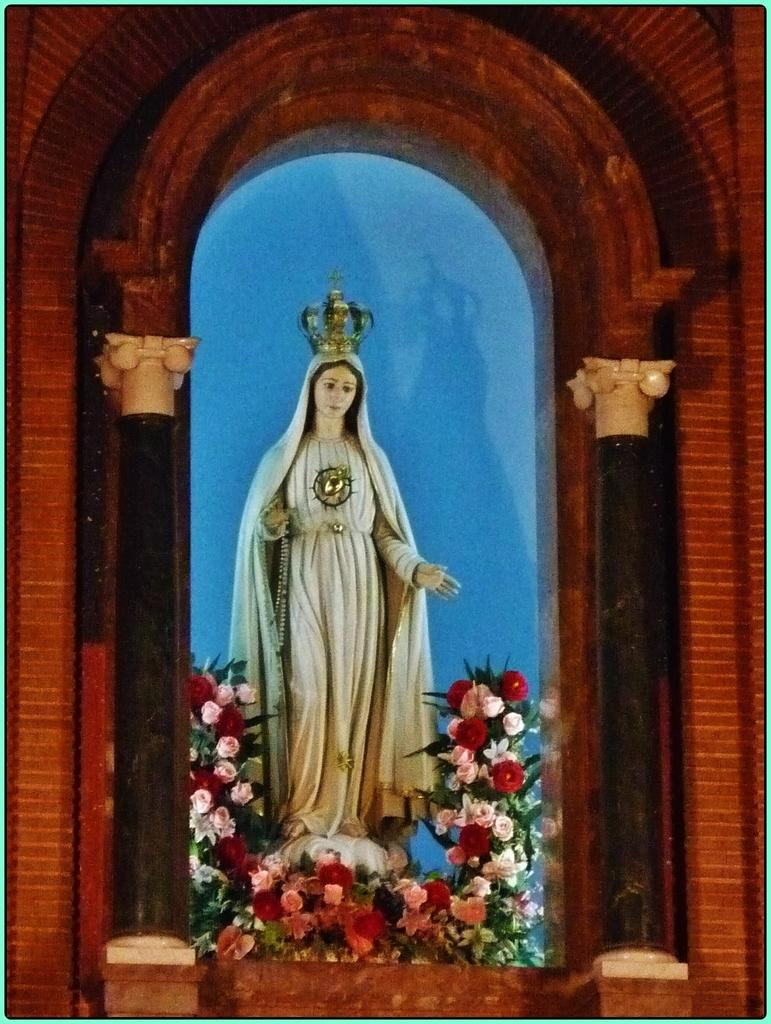What is located at the bottom of the image? There are flowers at the bottom of the image. What can be seen in the middle of the image? There is a statue in the middle of the image. What type of hair can be seen on the statue in the image? There is no hair visible on the statue in the image. How many bikes are present in the image? There are no bikes present in the image. 